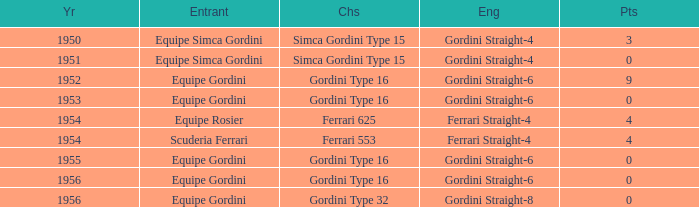What chassis has smaller than 9 points by Equipe Rosier? Ferrari 625. 